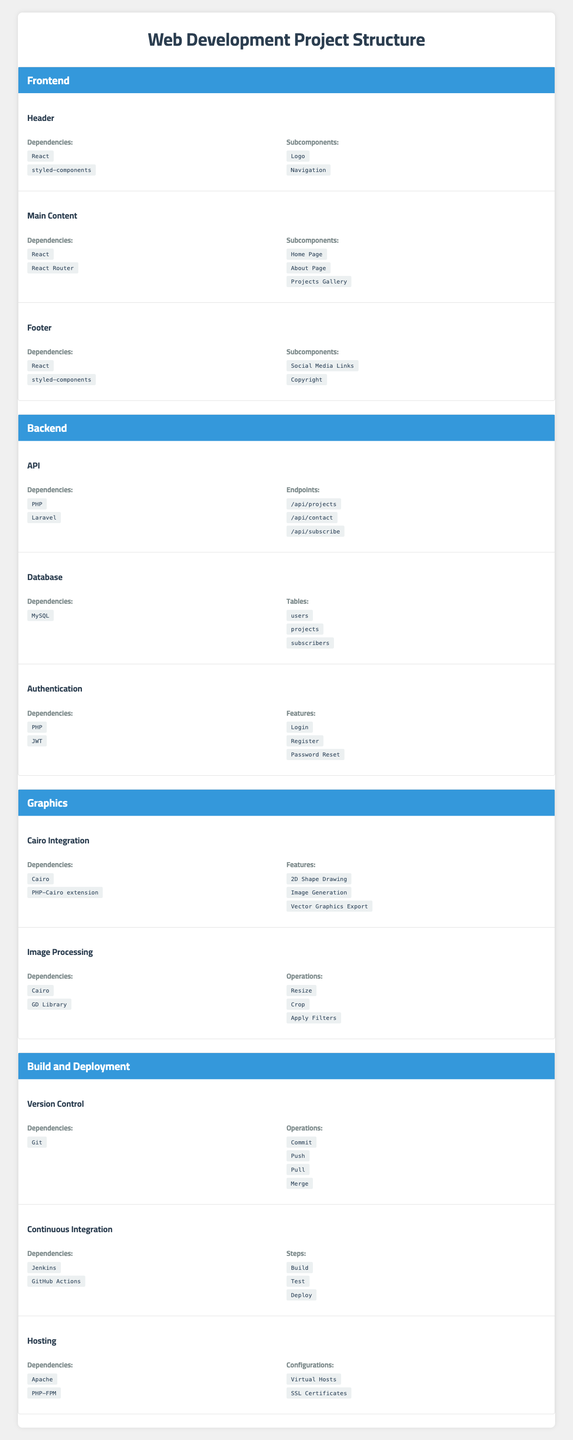What components make up the Frontend section? The Frontend section includes the components: Header, Main Content, and Footer. These can be found in the listed components under the Frontend category.
Answer: Header, Main Content, Footer How many Dependencies does the Footer have? The Footer component has two dependencies: React and styled-components, which are specifically listed in its details.
Answer: 2 Which component has the least number of Subcomponents? The Header component has the least number of subcomponents, with only two (Logo and Navigation), compared to others that have more.
Answer: Header Is MySQL a dependency for the API component? No, MySQL is not listed as a dependency for the API component. The API depends on PHP and Laravel.
Answer: No What features are provided by the Authentication component? The Authentication component features Login, Register, and Password Reset, which are specifically mentioned under its details.
Answer: Login, Register, Password Reset Which section has a component for graphics integration? The Graphics section includes the component for Cairo Integration, which is specifically designated for graphics integration.
Answer: Graphics How many different types of Operations does the Image Processing component perform? The Image Processing component performs three different operations: Resize, Crop, and Apply Filters, as detailed in its section.
Answer: 3 What dependencies does the Continuous Integration component rely on? The Continuous Integration component relies on Jenkins and GitHub Actions, which are explicitly listed under its dependencies.
Answer: Jenkins, GitHub Actions Which section contains a component related to Version Control? The Build and Deployment section contains the component related to Version Control, explicitly listed as part of its components.
Answer: Build and Deployment If you count all Subcomponents in the Frontend section, how many are there in total? The total Subcomponents in the Frontend section is 5, accounting for 2 from the Header, 3 from Main Content, and 2 from the Footer (2 + 3 + 2 = 7).
Answer: 7 Are the dependencies for the Graphics section identical to any other section? No, the dependencies for the Graphics section (Cairo and PHP-Cairo extension) are unique and do not match those listed in any other section.
Answer: No 